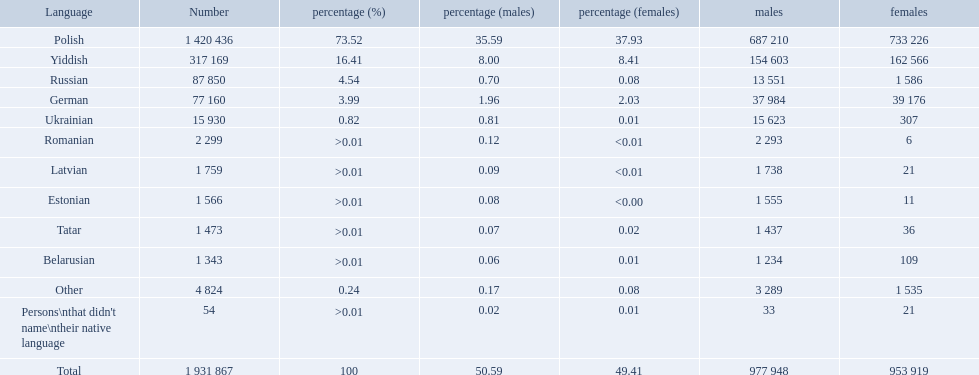What languages are spoken in the warsaw governorate? Polish, Yiddish, Russian, German, Ukrainian, Romanian, Latvian, Estonian, Tatar, Belarusian. Which are the top five languages? Polish, Yiddish, Russian, German, Ukrainian. Of those which is the 2nd most frequently spoken? Yiddish. How many languages are there? Polish, Yiddish, Russian, German, Ukrainian, Romanian, Latvian, Estonian, Tatar, Belarusian. Which language do more people speak? Polish. What are all the spoken languages? Polish, Yiddish, Russian, German, Ukrainian, Romanian, Latvian, Estonian, Tatar, Belarusian. Which one of these has the most people speaking it? Polish. What languages are spoken in the warsaw governorate? Polish, Yiddish, Russian, German, Ukrainian, Romanian, Latvian, Estonian, Tatar, Belarusian, Other, Persons\nthat didn't name\ntheir native language. What is the number for russian? 87 850. On this list what is the next lowest number? 77 160. Which language has a number of 77160 speakers? German. 